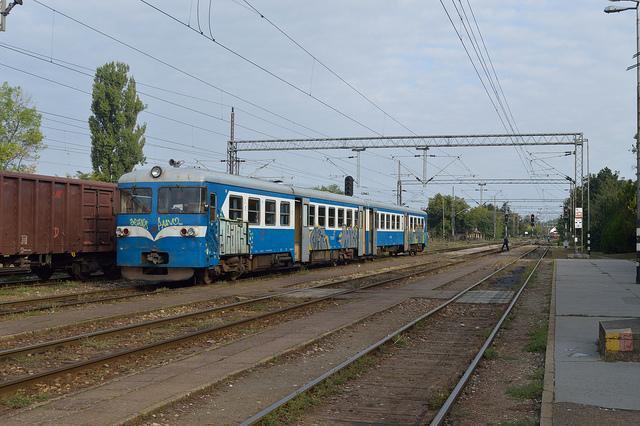What is the name of the painting on the outside of the blue train?
From the following four choices, select the correct answer to address the question.
Options: Fine art, acrylic, graffiti, oil. Graffiti. 